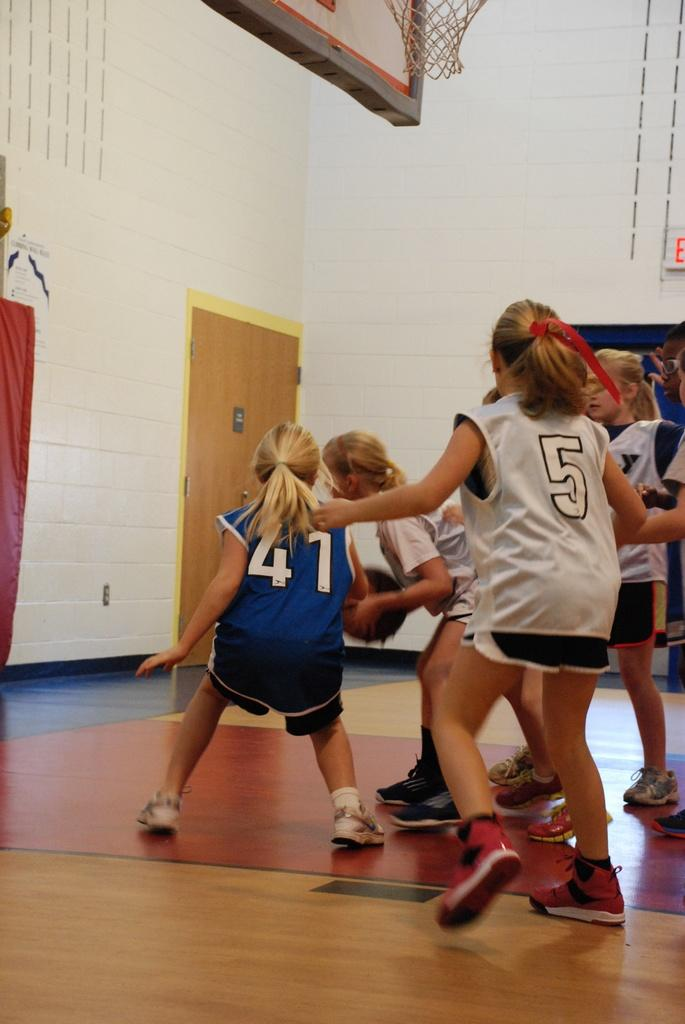<image>
Offer a succinct explanation of the picture presented. girls play basketball in a gym in numbered jerseys like 5 and 41 